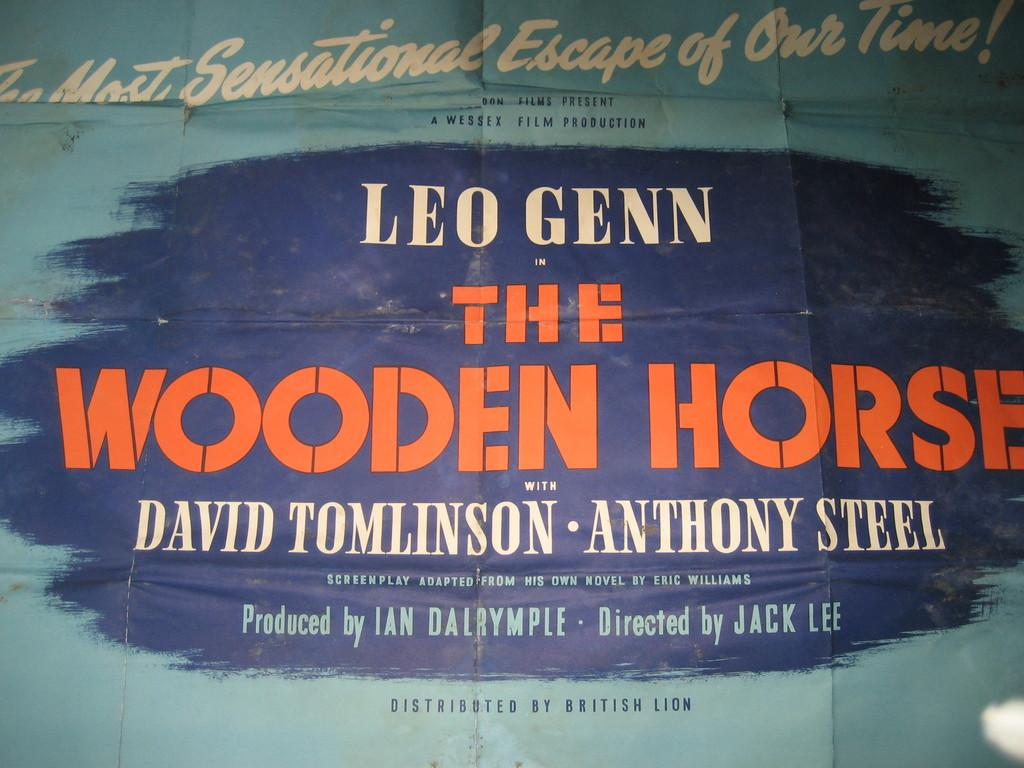What is located in the foreground of the image? There is a banner in the foreground of the image. What can be found on the banner? There is text written on the banner. How many clocks are displayed on the banner in the image? There are no clocks present on the banner in the image. What nation is represented by the banner in the image? The image does not provide enough information to determine the nation represented by the banner. 